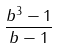Convert formula to latex. <formula><loc_0><loc_0><loc_500><loc_500>\frac { b ^ { 3 } - 1 } { b - 1 }</formula> 